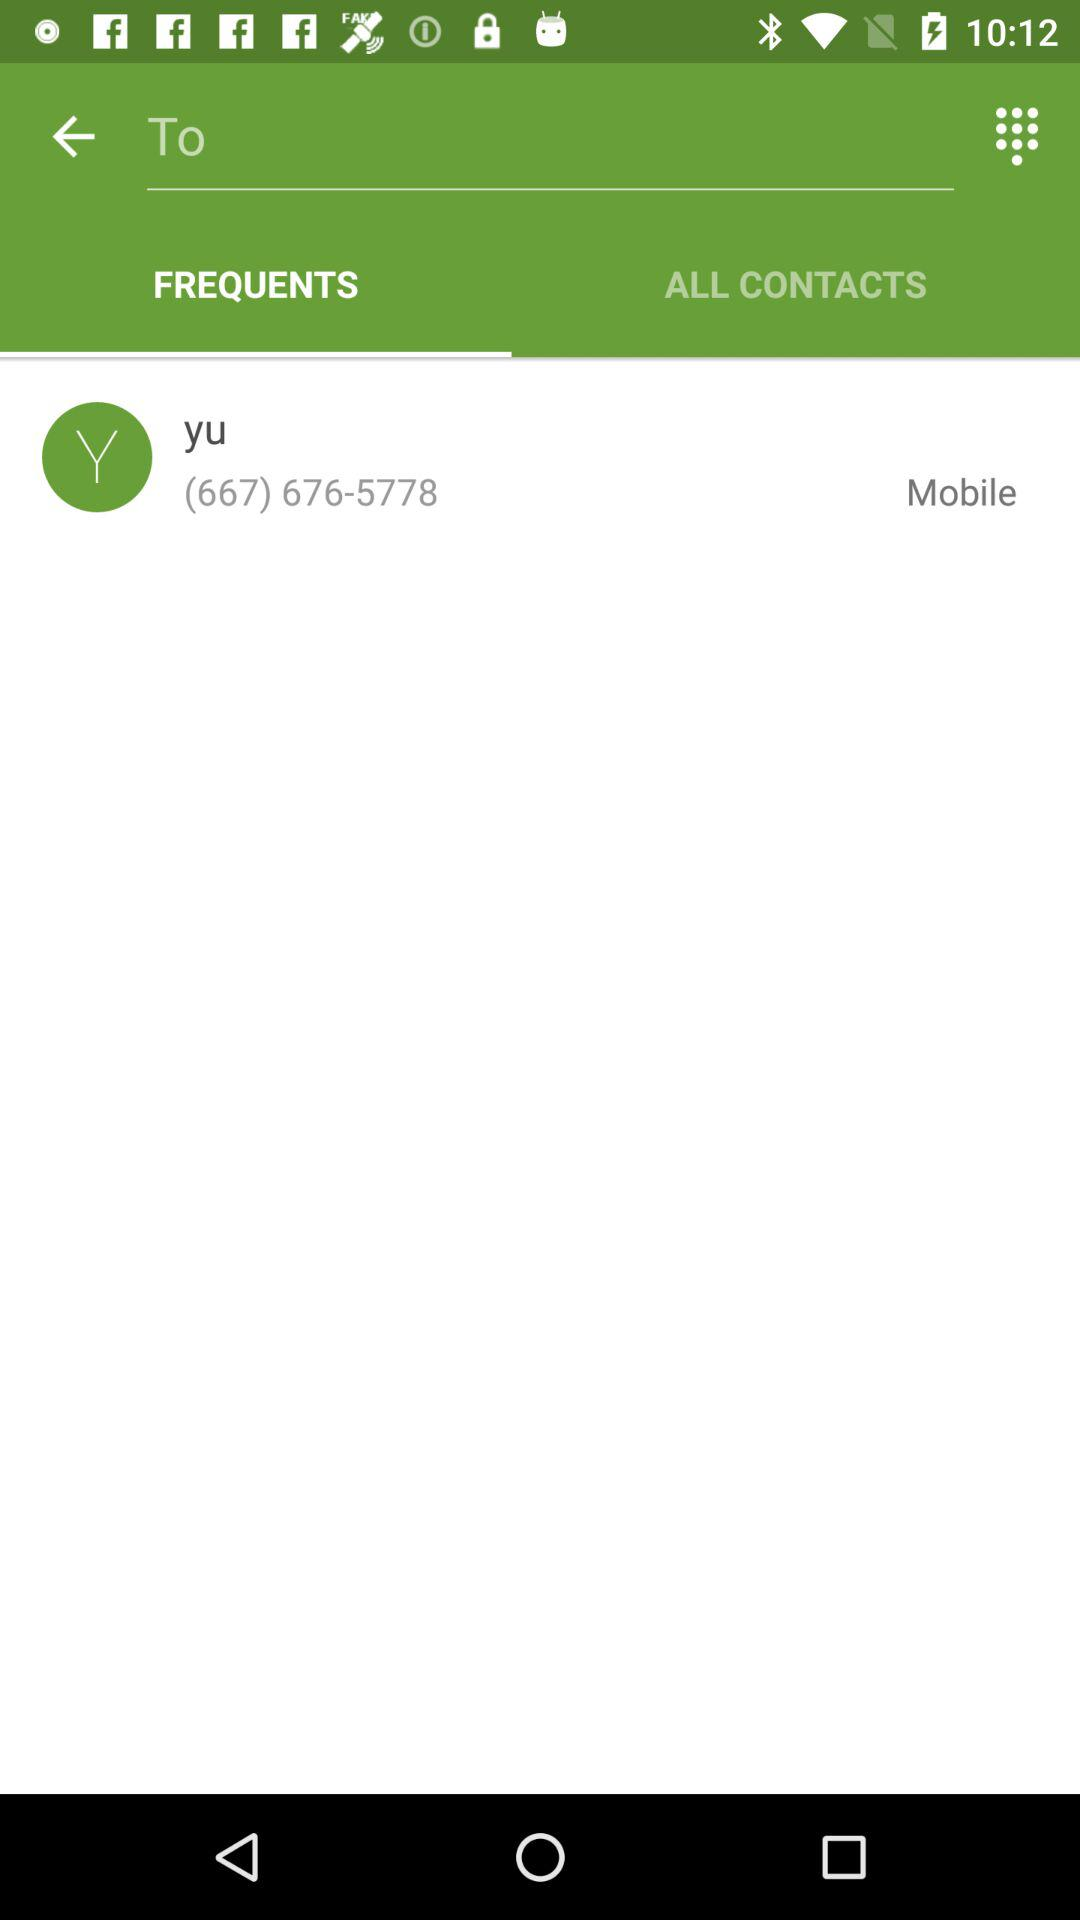What is the contact number for Yu? The contact number for Yu is (667) 676-5778. 